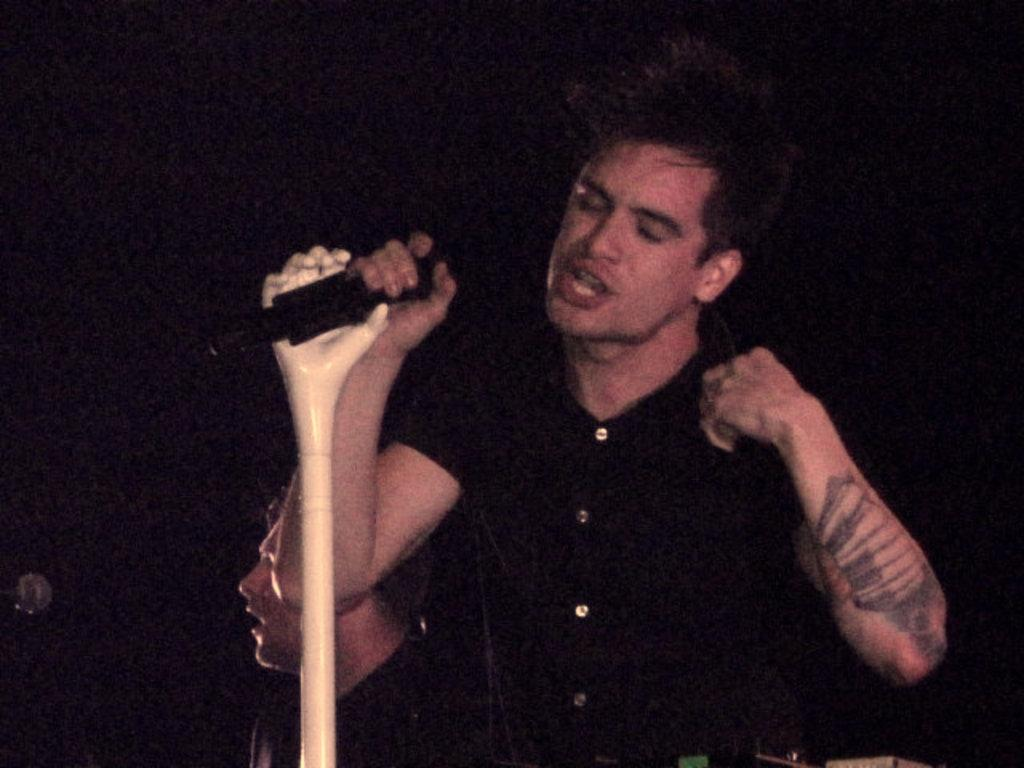What is the main subject of the image? There is a man in the image. What is the man wearing? The man is wearing a black shirt. What is the man holding in his hand? The man is holding a mic in his hand. Can you describe the person standing behind the man? There is another person standing behind the man, but their appearance is not described in the facts. What is the color of the background in the image? The background of the image is completely dark. What advice does the man's uncle give him in the image? There is no mention of an uncle or any advice being given in the image. 